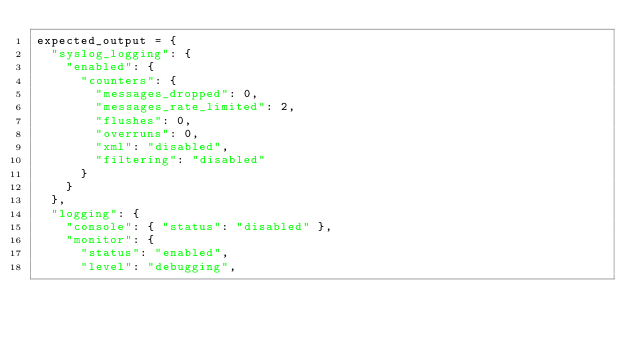Convert code to text. <code><loc_0><loc_0><loc_500><loc_500><_Python_>expected_output = {
  "syslog_logging": {
    "enabled": {
      "counters": {
        "messages_dropped": 0,
        "messages_rate_limited": 2,
        "flushes": 0,
        "overruns": 0,
        "xml": "disabled",
        "filtering": "disabled"
      }
    }
  },
  "logging": {
    "console": { "status": "disabled" },
    "monitor": {
      "status": "enabled",
      "level": "debugging",</code> 